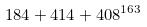Convert formula to latex. <formula><loc_0><loc_0><loc_500><loc_500>1 8 4 + 4 1 4 + 4 0 8 ^ { 1 6 3 }</formula> 